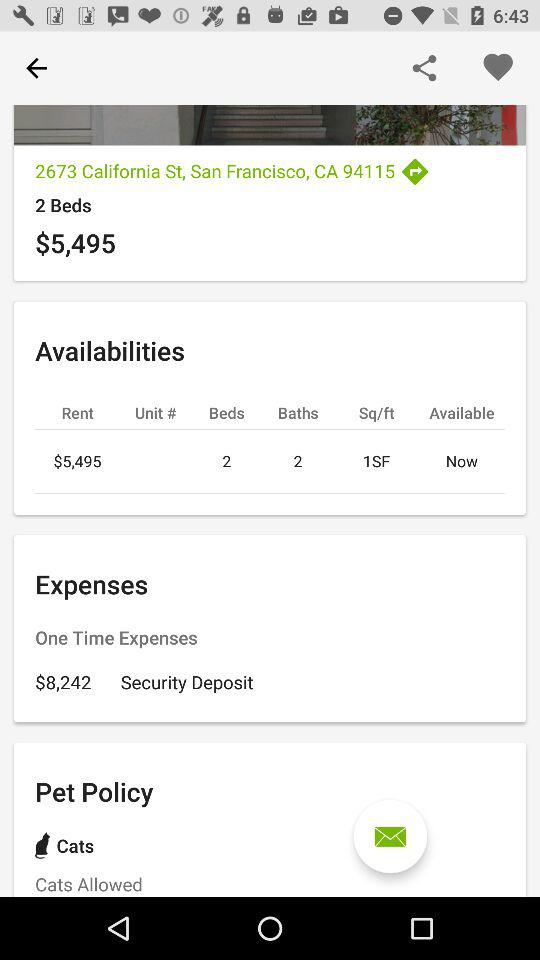How many cats allowed?
When the provided information is insufficient, respond with <no answer>. <no answer> 